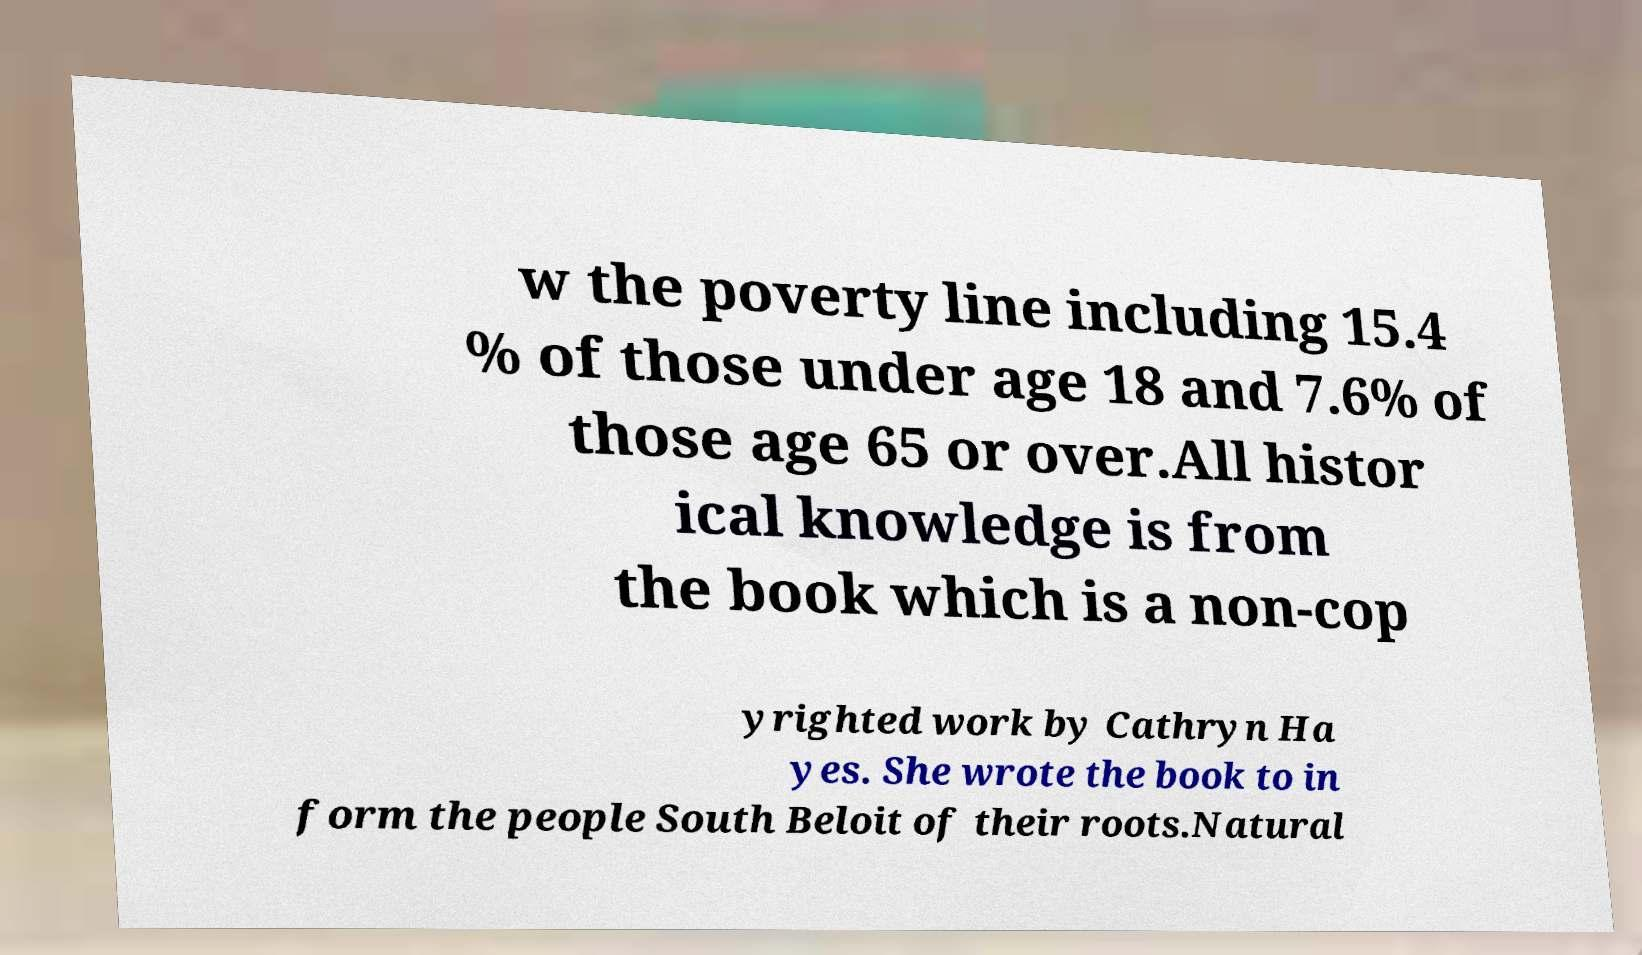Could you extract and type out the text from this image? w the poverty line including 15.4 % of those under age 18 and 7.6% of those age 65 or over.All histor ical knowledge is from the book which is a non-cop yrighted work by Cathryn Ha yes. She wrote the book to in form the people South Beloit of their roots.Natural 